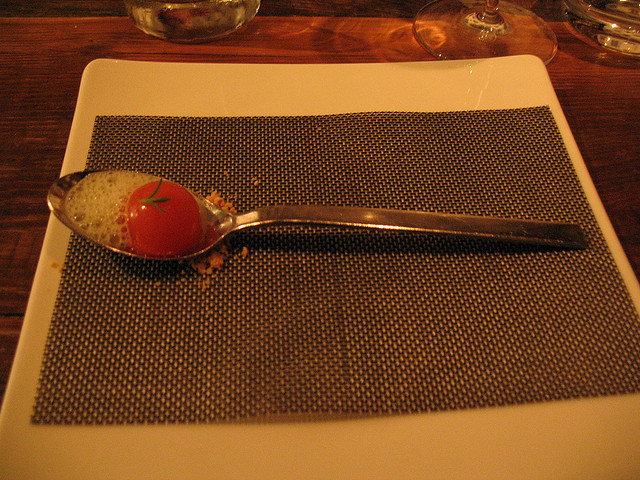Can you describe what is on the spoon? On the spoon, there is a carefully presented item that resembles a ripe tomato. However, upon closer inspection, it appears to be a delicate and creative culinary presentation that mimics the look of a tomato. 